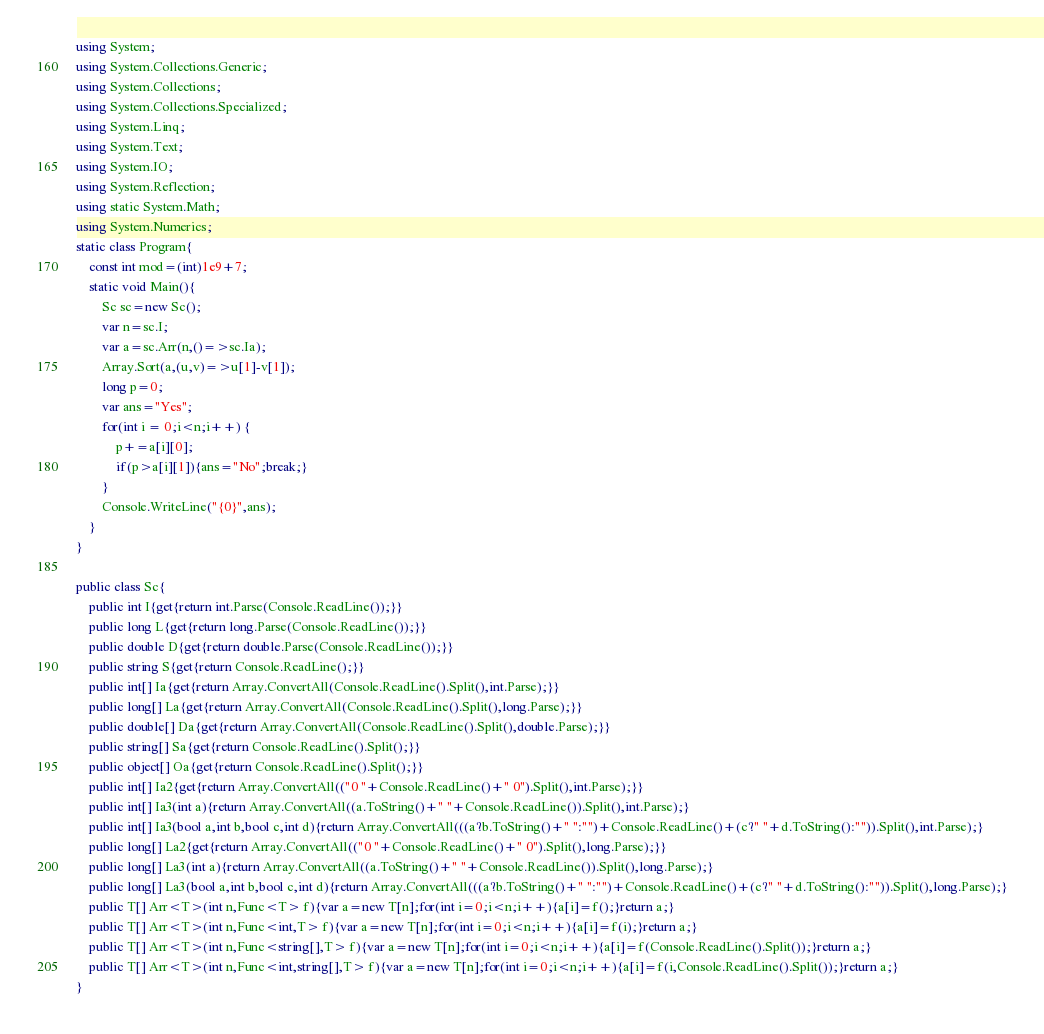<code> <loc_0><loc_0><loc_500><loc_500><_C#_>using System;
using System.Collections.Generic;
using System.Collections;
using System.Collections.Specialized;
using System.Linq;
using System.Text;
using System.IO;
using System.Reflection;
using static System.Math;
using System.Numerics;
static class Program{
	const int mod=(int)1e9+7;
	static void Main(){
		Sc sc=new Sc();
		var n=sc.I;
		var a=sc.Arr(n,()=>sc.Ia);
		Array.Sort(a,(u,v)=>u[1]-v[1]);
		long p=0;
		var ans="Yes";
		for(int i = 0;i<n;i++) {
			p+=a[i][0];
			if(p>a[i][1]){ans="No";break;}
		}
		Console.WriteLine("{0}",ans);
	}
}

public class Sc{
	public int I{get{return int.Parse(Console.ReadLine());}}
	public long L{get{return long.Parse(Console.ReadLine());}}
	public double D{get{return double.Parse(Console.ReadLine());}}
	public string S{get{return Console.ReadLine();}}
	public int[] Ia{get{return Array.ConvertAll(Console.ReadLine().Split(),int.Parse);}}
	public long[] La{get{return Array.ConvertAll(Console.ReadLine().Split(),long.Parse);}}
	public double[] Da{get{return Array.ConvertAll(Console.ReadLine().Split(),double.Parse);}}
	public string[] Sa{get{return Console.ReadLine().Split();}}
	public object[] Oa{get{return Console.ReadLine().Split();}}
	public int[] Ia2{get{return Array.ConvertAll(("0 "+Console.ReadLine()+" 0").Split(),int.Parse);}}
	public int[] Ia3(int a){return Array.ConvertAll((a.ToString()+" "+Console.ReadLine()).Split(),int.Parse);}
	public int[] Ia3(bool a,int b,bool c,int d){return Array.ConvertAll(((a?b.ToString()+" ":"")+Console.ReadLine()+(c?" "+d.ToString():"")).Split(),int.Parse);}
	public long[] La2{get{return Array.ConvertAll(("0 "+Console.ReadLine()+" 0").Split(),long.Parse);}}
	public long[] La3(int a){return Array.ConvertAll((a.ToString()+" "+Console.ReadLine()).Split(),long.Parse);}
	public long[] La3(bool a,int b,bool c,int d){return Array.ConvertAll(((a?b.ToString()+" ":"")+Console.ReadLine()+(c?" "+d.ToString():"")).Split(),long.Parse);}
	public T[] Arr<T>(int n,Func<T> f){var a=new T[n];for(int i=0;i<n;i++){a[i]=f();}return a;}
	public T[] Arr<T>(int n,Func<int,T> f){var a=new T[n];for(int i=0;i<n;i++){a[i]=f(i);}return a;}
	public T[] Arr<T>(int n,Func<string[],T> f){var a=new T[n];for(int i=0;i<n;i++){a[i]=f(Console.ReadLine().Split());}return a;}
	public T[] Arr<T>(int n,Func<int,string[],T> f){var a=new T[n];for(int i=0;i<n;i++){a[i]=f(i,Console.ReadLine().Split());}return a;}
}
</code> 